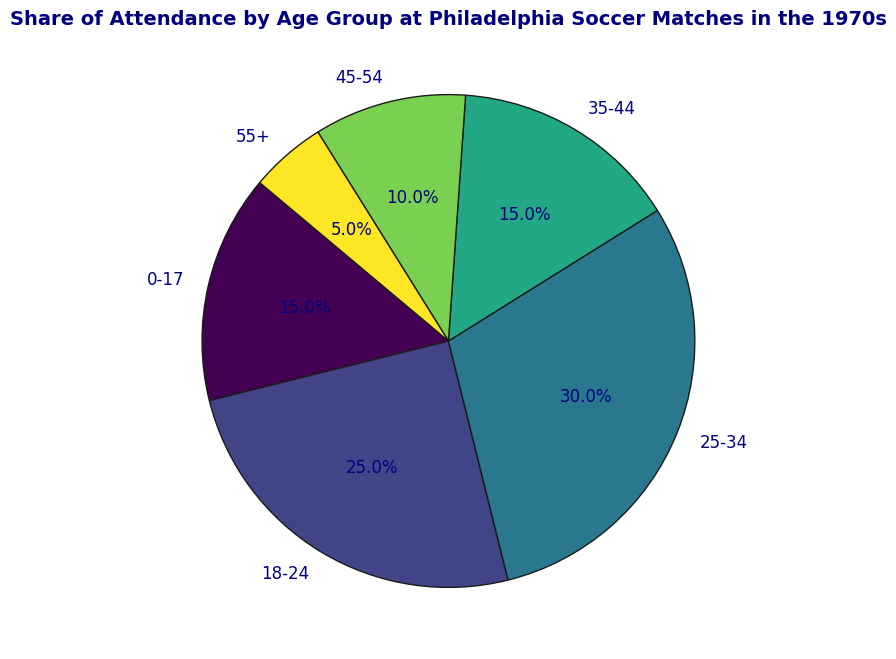What's the share of attendance for the age group 25-34? By looking at the segment labeled "25-34," the share of attendance is directly provided.
Answer: 30% Which age group has the least share of attendance? By examining the pie chart, the smallest segment belongs to the "55+" age group.
Answer: 55+ What's the combined share of attendance for the age groups 0-17 and 35-44? To find this, add the share of attendance for both age groups: 15% (0-17) + 15% (35-44).
Answer: 30% How much more share of attendance does the age group 25-34 have compared to the 45-54 age group? Subtract the share of the 45-54 age group (10%) from the 25-34 age group (30%): 30% - 10%.
Answer: 20% If the total attendance was 10,000 people, how many attendees were from the 18-24 age group? Calculate 25% of 10,000: 10,000 * 0.25 = 2,500.
Answer: 2,500 Which two age groups have an equal share of attendance? The pie chart shows that the age groups 0-17 and 35-44 both have a share of 15%.
Answer: 0-17 and 35-44 What is the difference in the share of attendance between the largest and smallest age groups? The largest age group is 25-34 with 30%, and the smallest is 55+ with 5%. The difference is 30% - 5%.
Answer: 25% What's the total share of attendance for age groups below 25 years? Add the shares of the age groups 0-17 (15%) and 18-24 (25%): 15% + 25%.
Answer: 40% What's the average share of attendance for the age groups 25-34, 35-44, and 45-54? Add the shares and divide by 3: (30% + 15% + 10%) / 3.
Answer: 18.3% Which age group has twice the share of attendance as the age group 0-17? The 0-17 age group's share is 15%, so twice its share is 30%. The 25-34 age group has a 30% share.
Answer: 25-34 